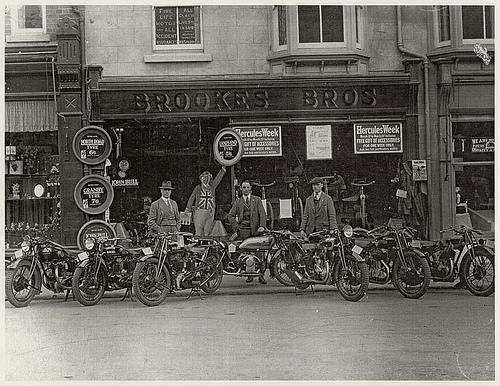How many real people are standing in front of the building?
Give a very brief answer. 3. 